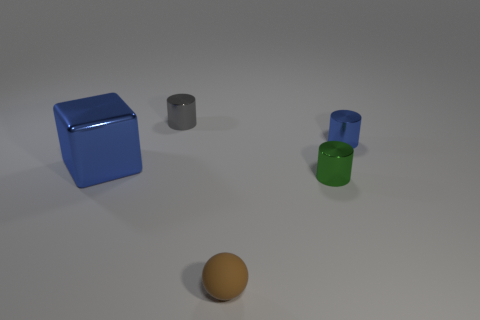Is there anything else that has the same material as the small ball?
Make the answer very short. No. What is the material of the blue cylinder?
Make the answer very short. Metal. What number of other things are the same size as the shiny block?
Make the answer very short. 0. There is a metallic thing on the left side of the gray metal thing; what size is it?
Keep it short and to the point. Large. The gray cylinder that is right of the blue shiny thing to the left of the small thing to the left of the small brown rubber ball is made of what material?
Your answer should be very brief. Metal. Do the big object and the tiny blue object have the same shape?
Ensure brevity in your answer.  No. How many rubber objects are large objects or tiny cylinders?
Make the answer very short. 0. How many brown rubber objects are there?
Your answer should be very brief. 1. There is a rubber thing that is the same size as the green shiny cylinder; what color is it?
Make the answer very short. Brown. Do the green shiny cylinder and the brown rubber object have the same size?
Make the answer very short. Yes. 